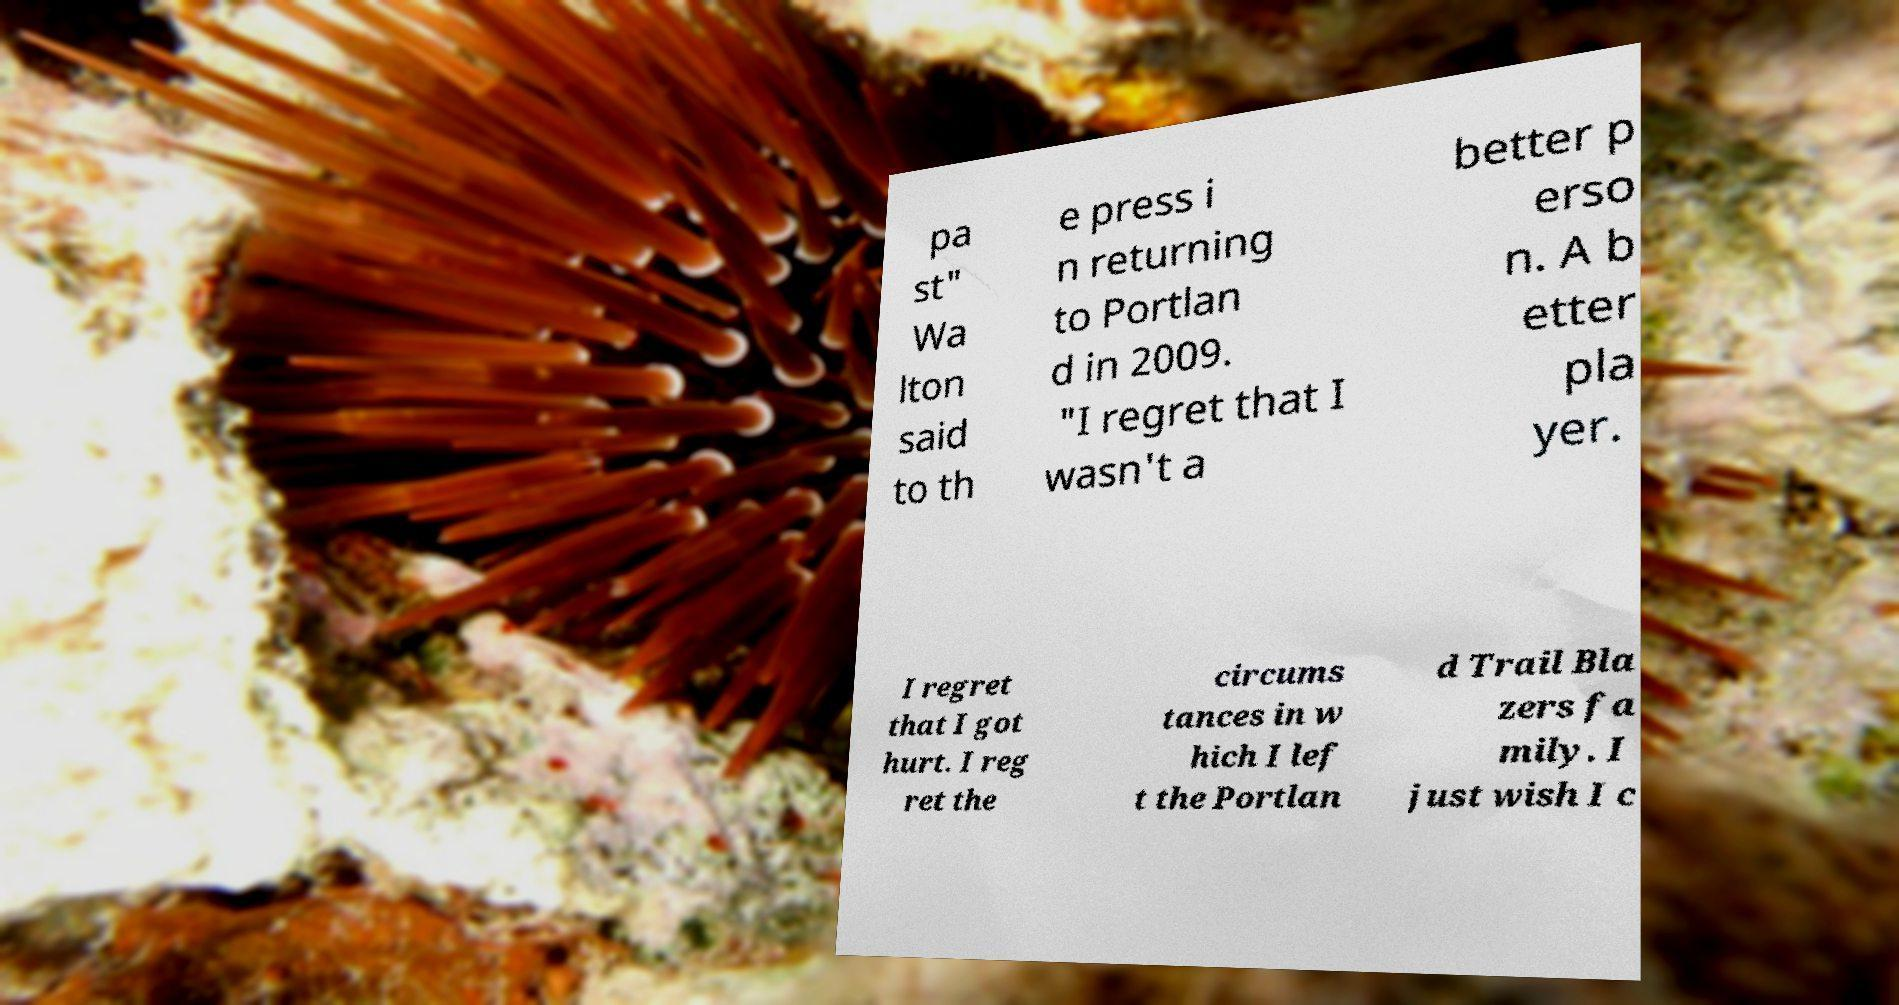Please read and relay the text visible in this image. What does it say? pa st" Wa lton said to th e press i n returning to Portlan d in 2009. "I regret that I wasn't a better p erso n. A b etter pla yer. I regret that I got hurt. I reg ret the circums tances in w hich I lef t the Portlan d Trail Bla zers fa mily. I just wish I c 